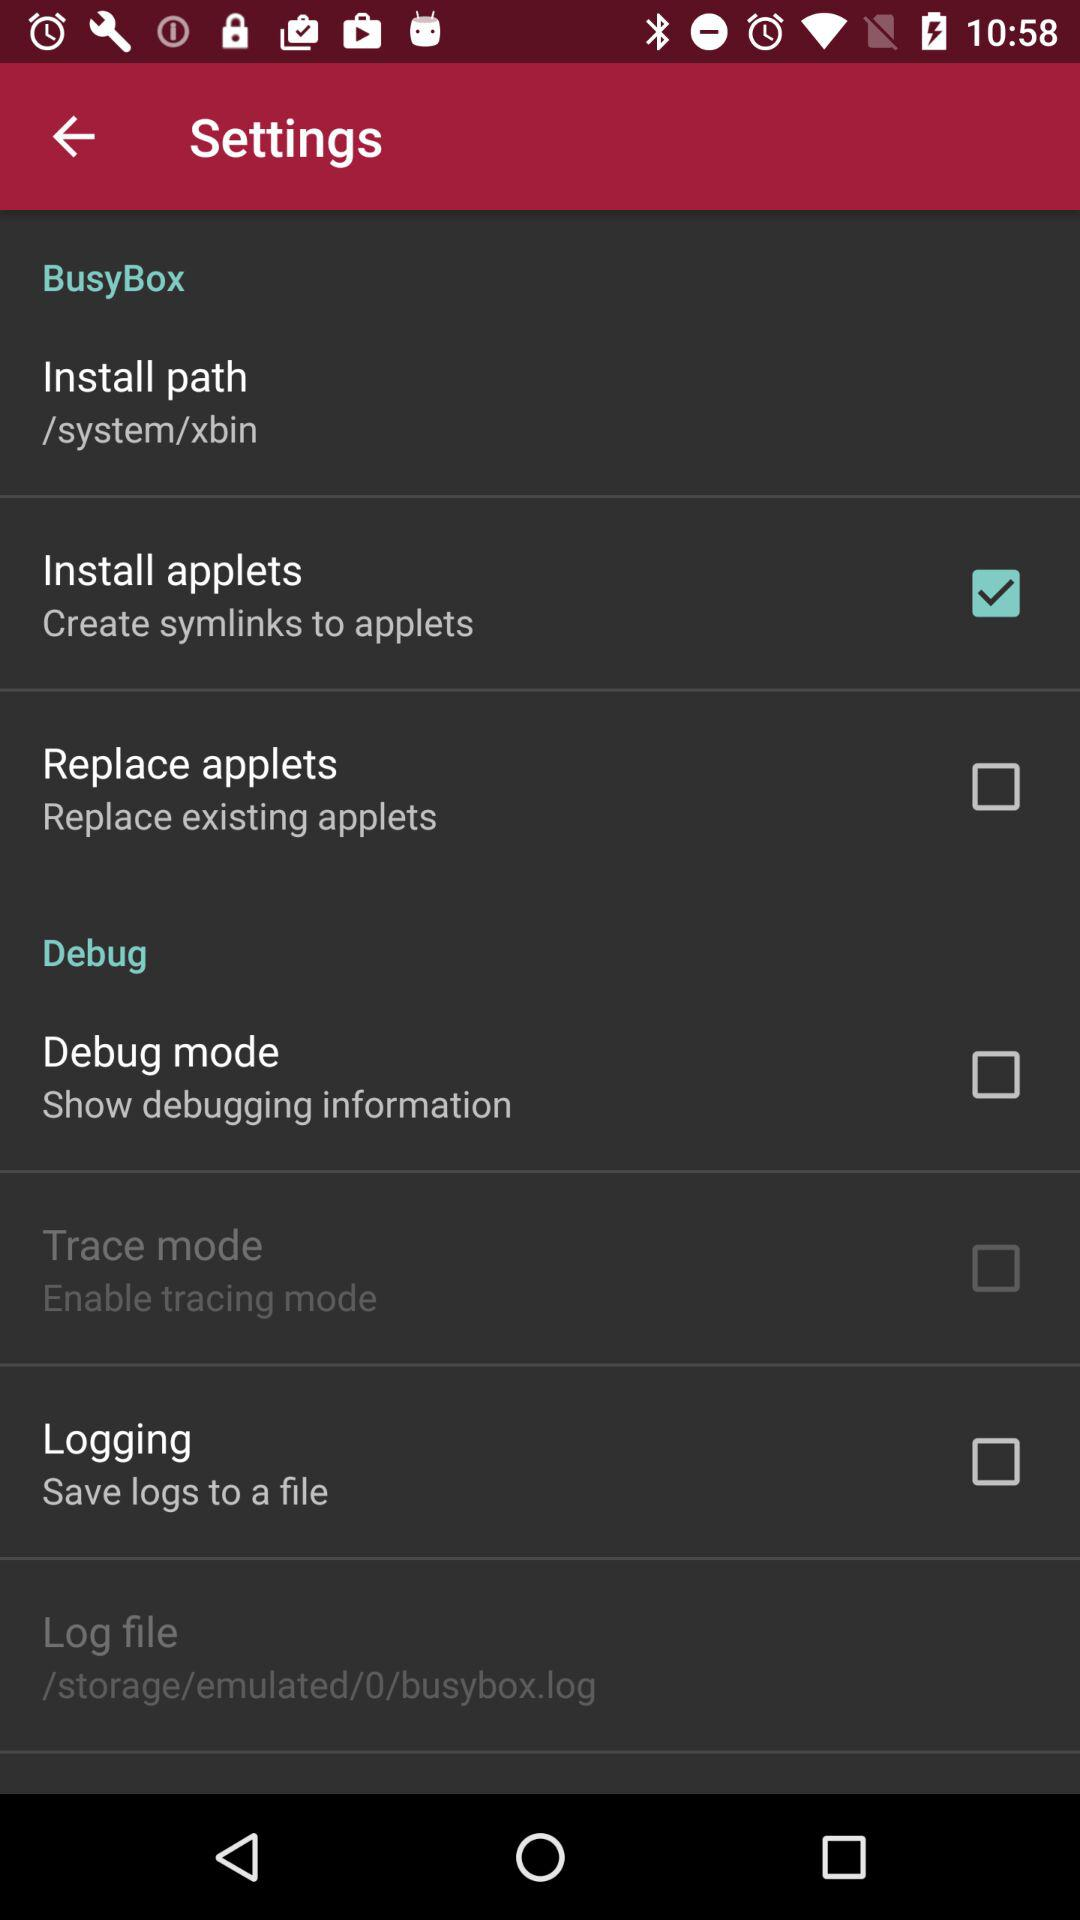What is the status of "Install applets"? The status is "on". 